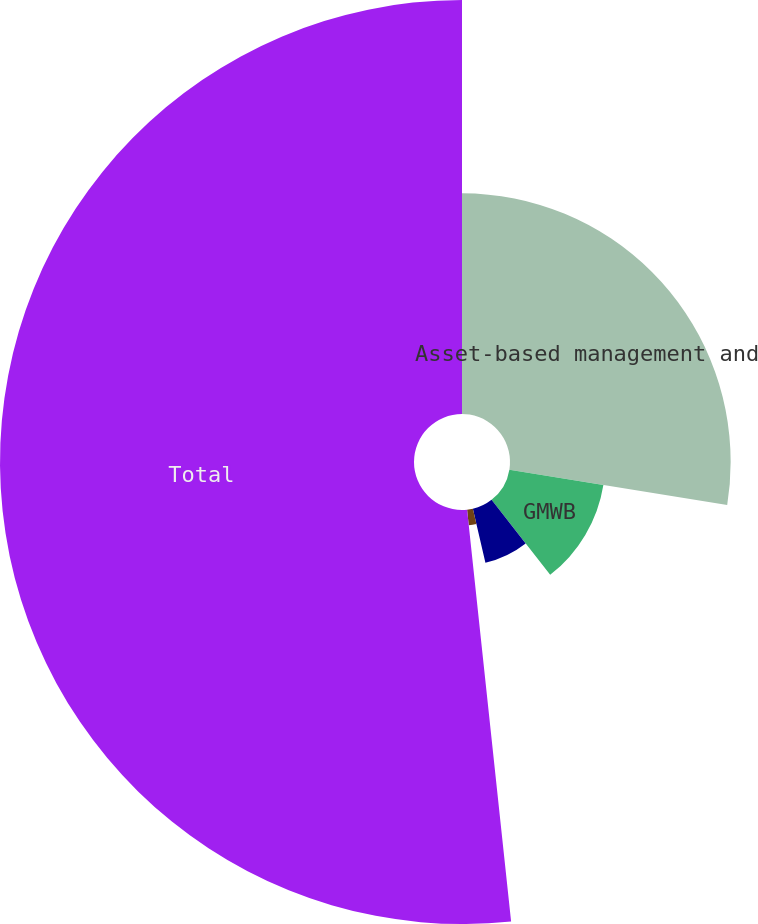Convert chart. <chart><loc_0><loc_0><loc_500><loc_500><pie_chart><fcel>Asset-based management and<fcel>GMWB<fcel>GMAB<fcel>Total variable annuity riders<fcel>Total<nl><fcel>27.55%<fcel>11.89%<fcel>6.92%<fcel>1.94%<fcel>51.69%<nl></chart> 